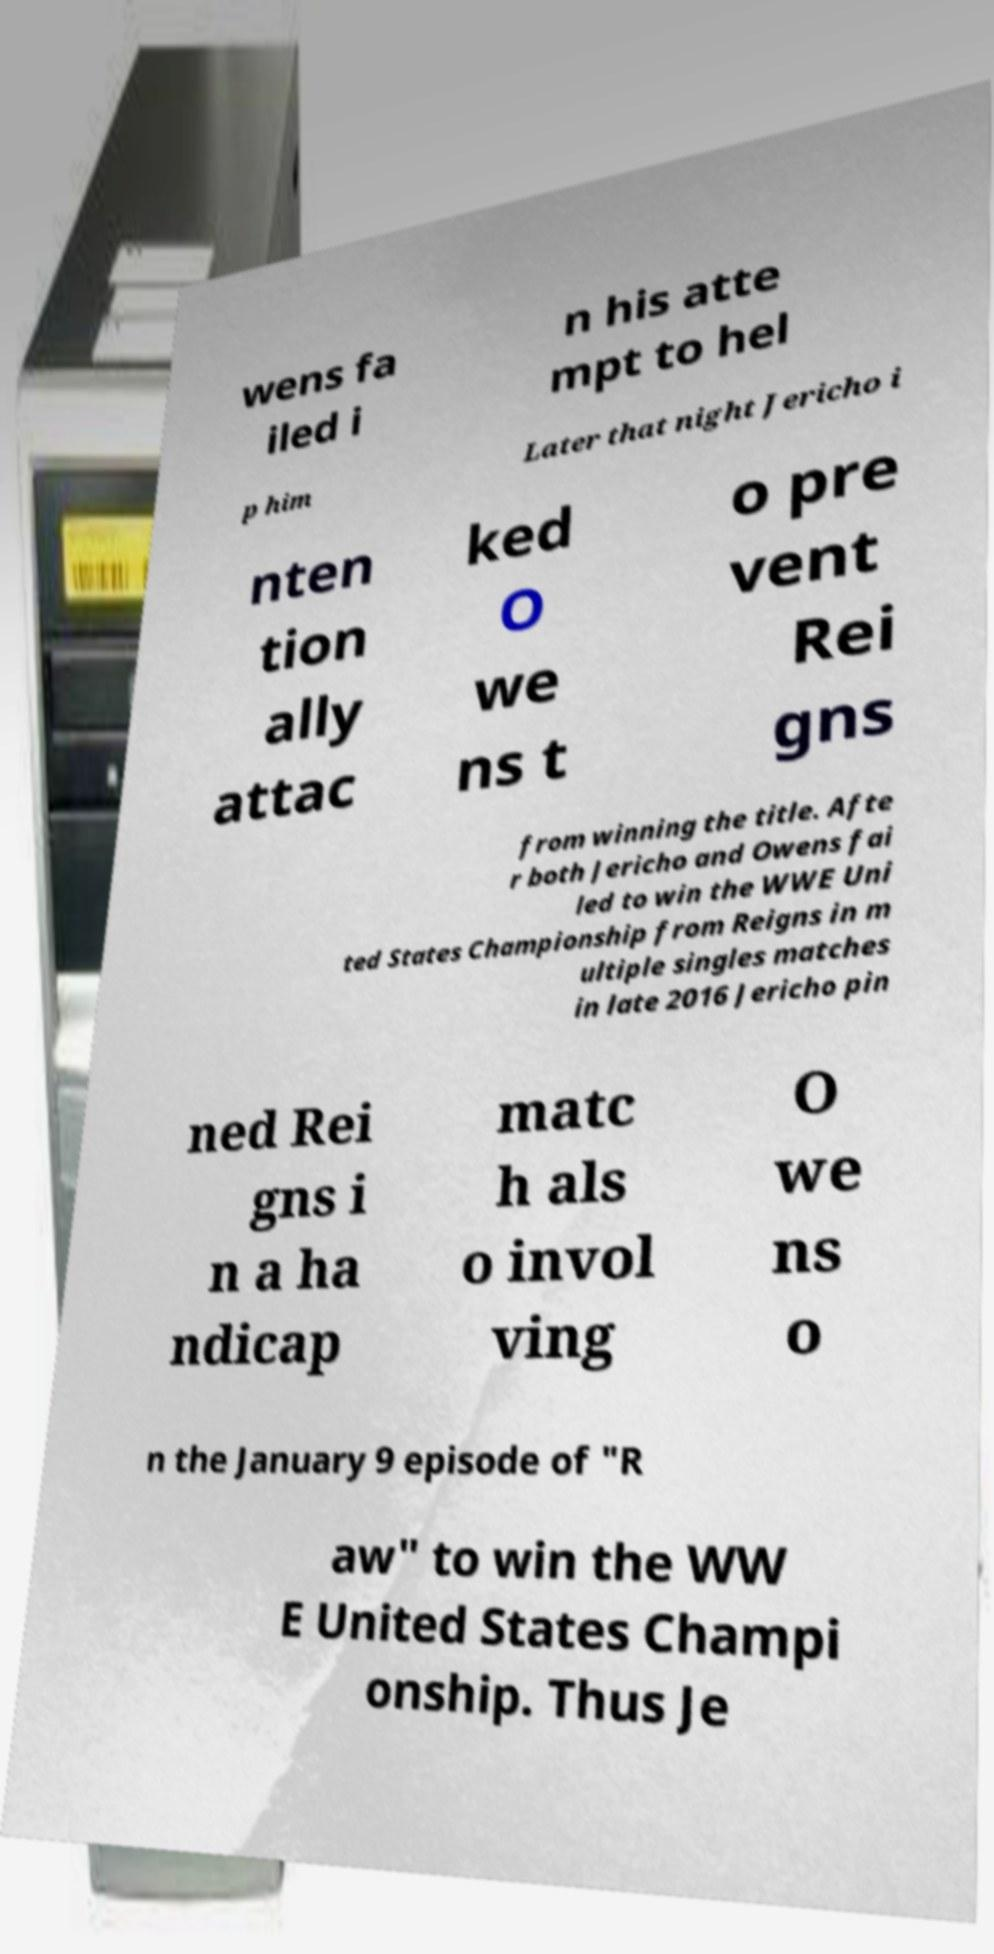I need the written content from this picture converted into text. Can you do that? wens fa iled i n his atte mpt to hel p him Later that night Jericho i nten tion ally attac ked O we ns t o pre vent Rei gns from winning the title. Afte r both Jericho and Owens fai led to win the WWE Uni ted States Championship from Reigns in m ultiple singles matches in late 2016 Jericho pin ned Rei gns i n a ha ndicap matc h als o invol ving O we ns o n the January 9 episode of "R aw" to win the WW E United States Champi onship. Thus Je 